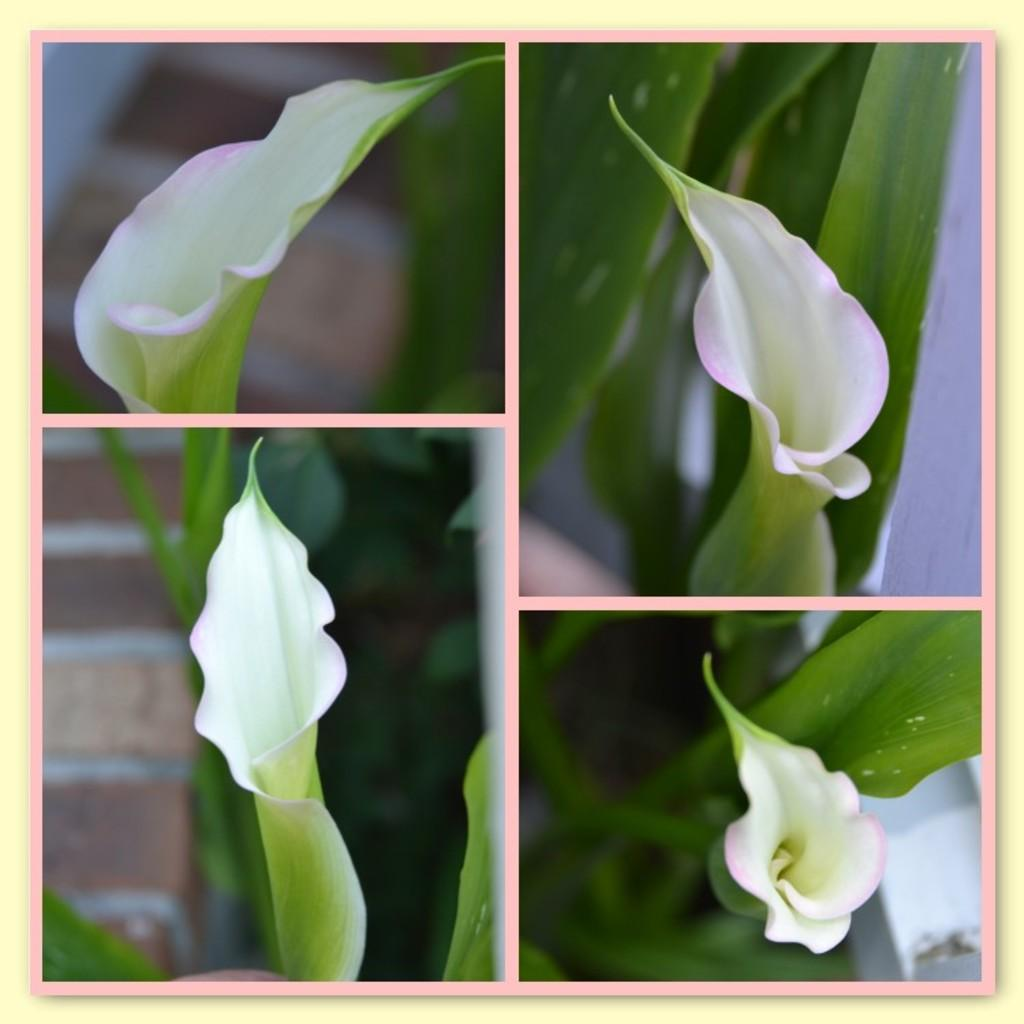How many pictures are included in the collage? The image is a collage of four pictures. What is the common subject in each picture of the collage? Each picture in the collage contains a flower. How does the presentation of the flower vary in each picture? The flower is shown from different angles in each picture. What type of cent can be seen interacting with the chalk in the image? There is no cent or chalk present in the image; it features a collage of four pictures, each containing a flower. What is the limit of the flowers shown in the image? There is no limit to the number of flowers shown in the image, as it is a collage of four pictures, each containing a flower. 